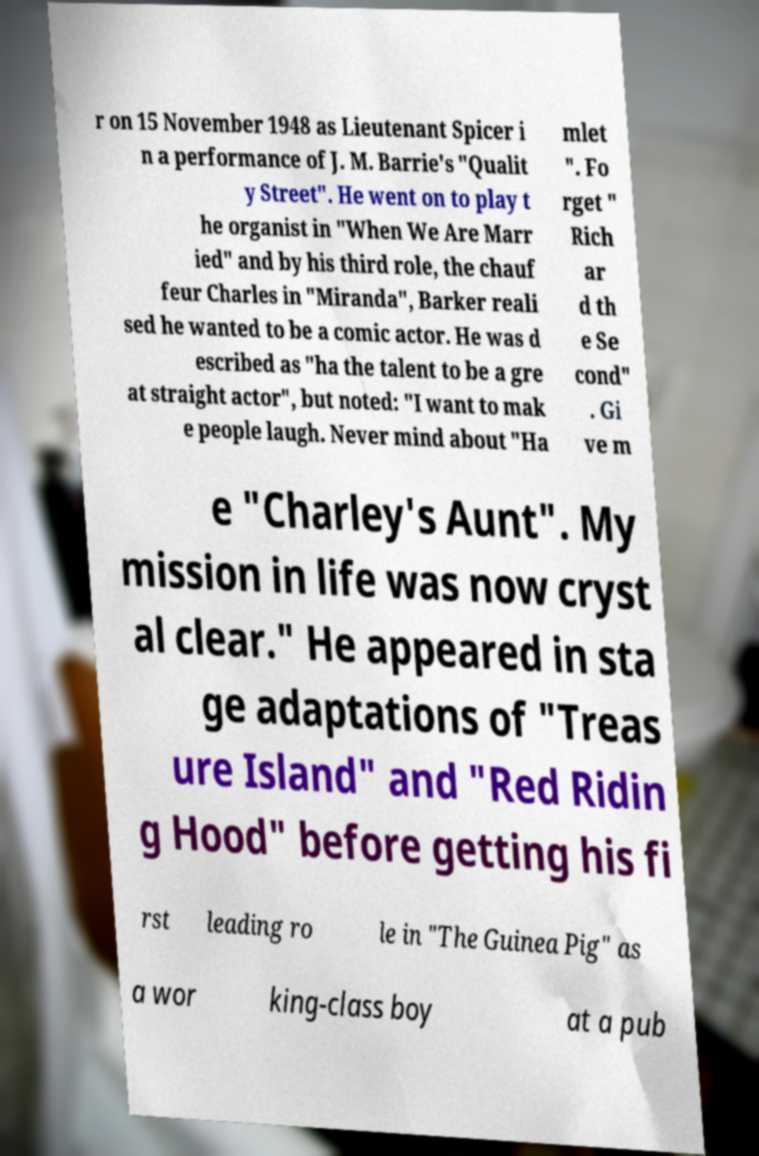I need the written content from this picture converted into text. Can you do that? r on 15 November 1948 as Lieutenant Spicer i n a performance of J. M. Barrie's "Qualit y Street". He went on to play t he organist in "When We Are Marr ied" and by his third role, the chauf feur Charles in "Miranda", Barker reali sed he wanted to be a comic actor. He was d escribed as "ha the talent to be a gre at straight actor", but noted: "I want to mak e people laugh. Never mind about "Ha mlet ". Fo rget " Rich ar d th e Se cond" . Gi ve m e "Charley's Aunt". My mission in life was now cryst al clear." He appeared in sta ge adaptations of "Treas ure Island" and "Red Ridin g Hood" before getting his fi rst leading ro le in "The Guinea Pig" as a wor king-class boy at a pub 